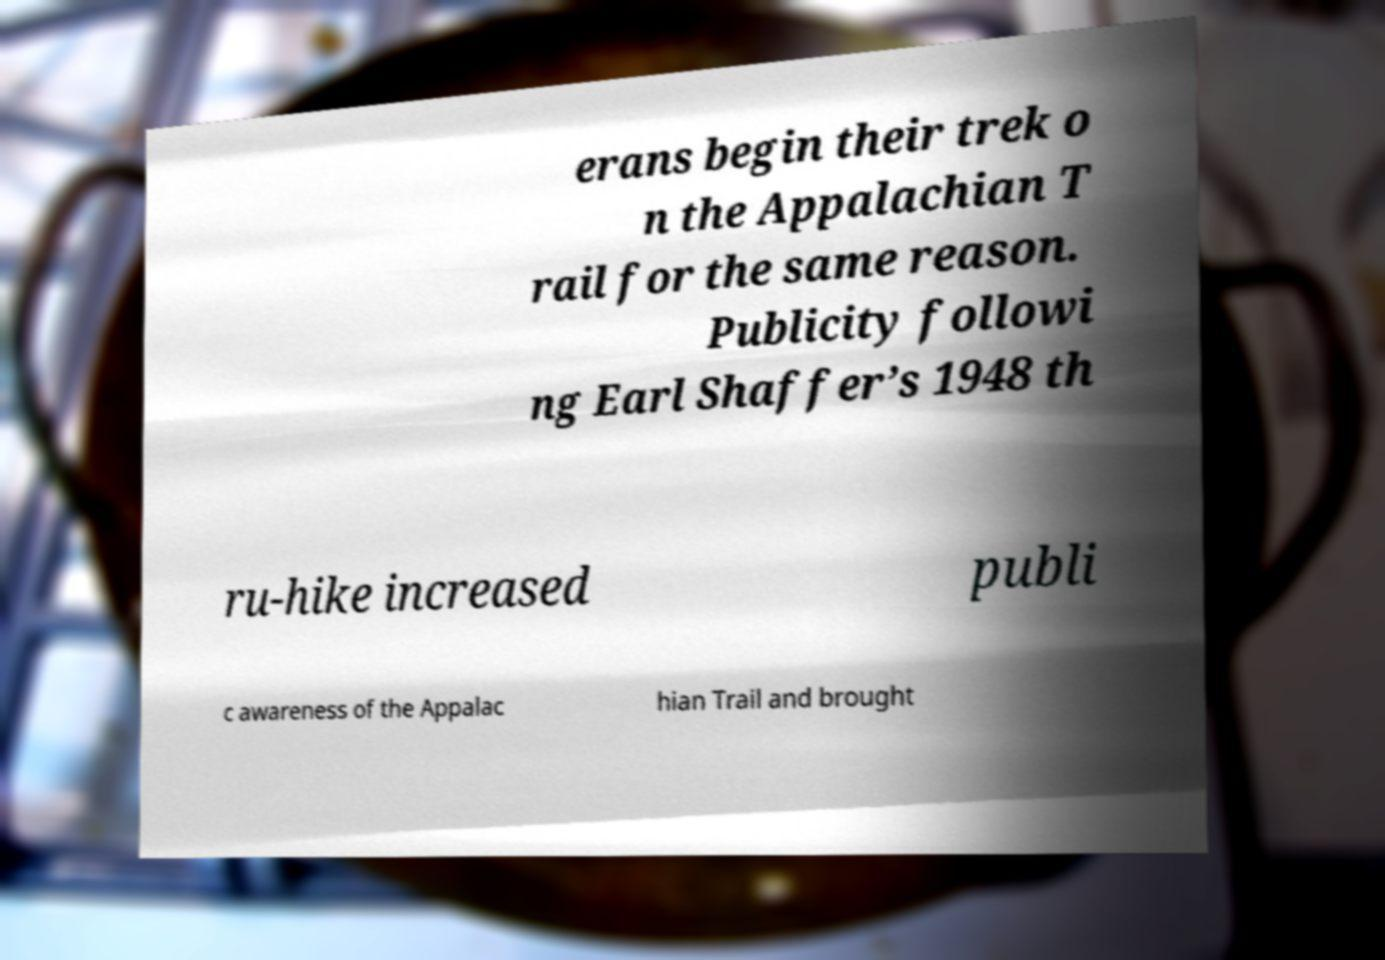Could you assist in decoding the text presented in this image and type it out clearly? erans begin their trek o n the Appalachian T rail for the same reason. Publicity followi ng Earl Shaffer’s 1948 th ru-hike increased publi c awareness of the Appalac hian Trail and brought 